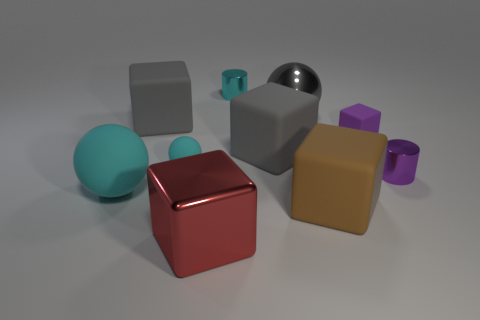Subtract all big metal cubes. How many cubes are left? 4 Subtract all red blocks. How many blocks are left? 4 Subtract 1 cubes. How many cubes are left? 4 Subtract all yellow blocks. Subtract all yellow balls. How many blocks are left? 5 Subtract all cylinders. How many objects are left? 8 Subtract all cyan cylinders. Subtract all gray objects. How many objects are left? 6 Add 2 gray spheres. How many gray spheres are left? 3 Add 3 red rubber spheres. How many red rubber spheres exist? 3 Subtract 1 brown blocks. How many objects are left? 9 